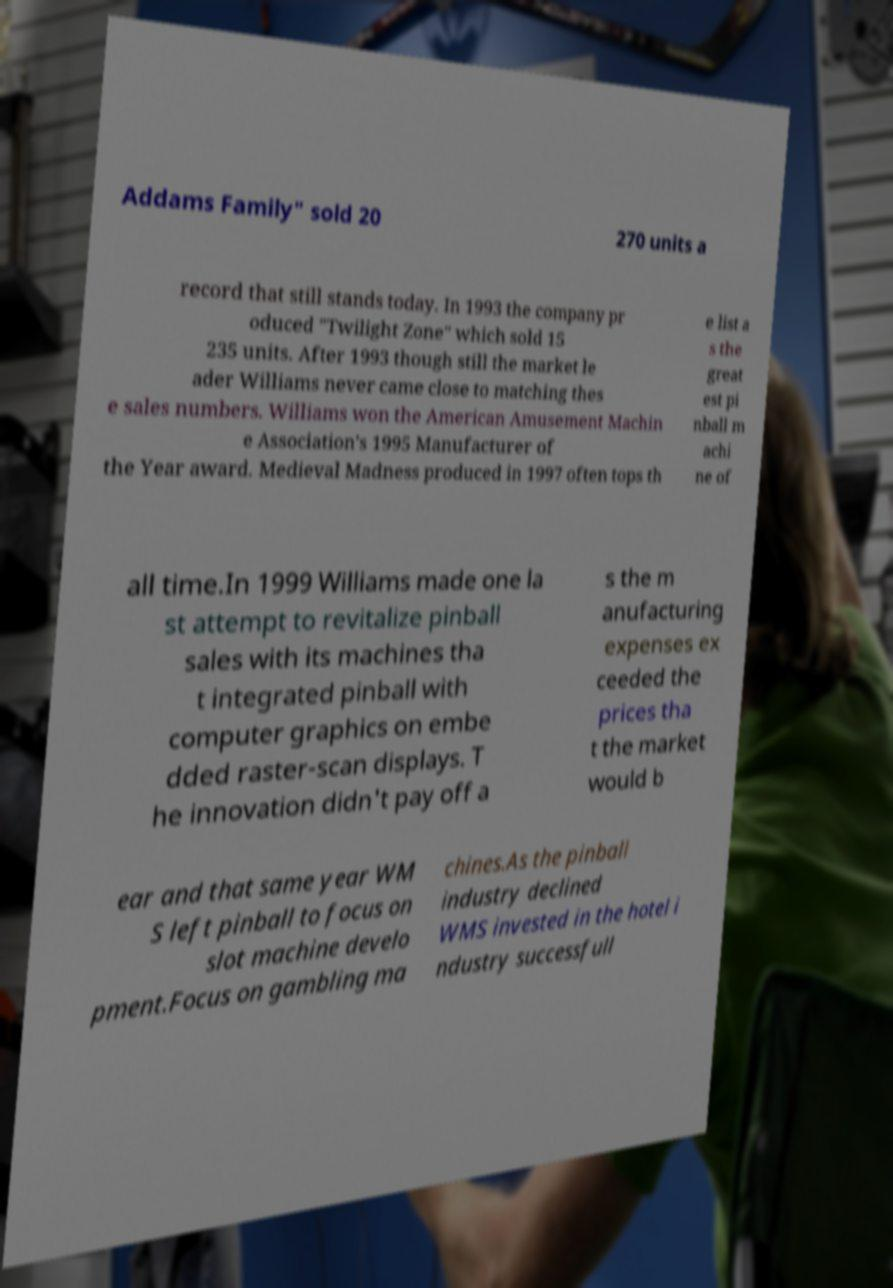Can you accurately transcribe the text from the provided image for me? Addams Family" sold 20 270 units a record that still stands today. In 1993 the company pr oduced "Twilight Zone" which sold 15 235 units. After 1993 though still the market le ader Williams never came close to matching thes e sales numbers. Williams won the American Amusement Machin e Association's 1995 Manufacturer of the Year award. Medieval Madness produced in 1997 often tops th e list a s the great est pi nball m achi ne of all time.In 1999 Williams made one la st attempt to revitalize pinball sales with its machines tha t integrated pinball with computer graphics on embe dded raster-scan displays. T he innovation didn't pay off a s the m anufacturing expenses ex ceeded the prices tha t the market would b ear and that same year WM S left pinball to focus on slot machine develo pment.Focus on gambling ma chines.As the pinball industry declined WMS invested in the hotel i ndustry successfull 